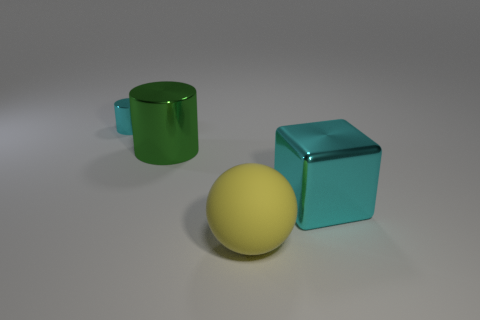Is the number of gray cylinders less than the number of yellow rubber balls? yes 